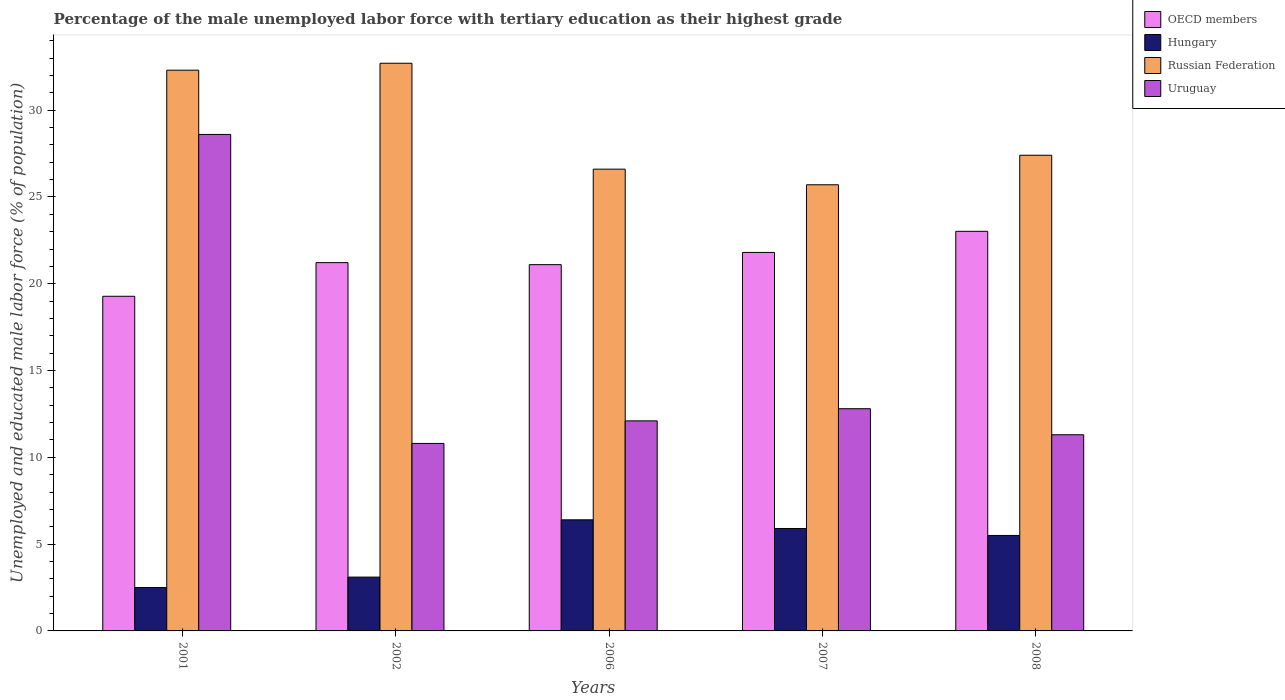How many different coloured bars are there?
Offer a very short reply. 4. How many groups of bars are there?
Your answer should be very brief. 5. Are the number of bars on each tick of the X-axis equal?
Provide a short and direct response. Yes. What is the label of the 3rd group of bars from the left?
Keep it short and to the point. 2006. What is the percentage of the unemployed male labor force with tertiary education in Russian Federation in 2006?
Offer a very short reply. 26.6. Across all years, what is the maximum percentage of the unemployed male labor force with tertiary education in OECD members?
Your answer should be very brief. 23.02. Across all years, what is the minimum percentage of the unemployed male labor force with tertiary education in Russian Federation?
Your response must be concise. 25.7. In which year was the percentage of the unemployed male labor force with tertiary education in Hungary minimum?
Provide a succinct answer. 2001. What is the total percentage of the unemployed male labor force with tertiary education in Hungary in the graph?
Make the answer very short. 23.4. What is the difference between the percentage of the unemployed male labor force with tertiary education in Hungary in 2002 and that in 2008?
Provide a short and direct response. -2.4. What is the difference between the percentage of the unemployed male labor force with tertiary education in Russian Federation in 2008 and the percentage of the unemployed male labor force with tertiary education in Uruguay in 2001?
Keep it short and to the point. -1.2. What is the average percentage of the unemployed male labor force with tertiary education in OECD members per year?
Offer a very short reply. 21.28. In the year 2001, what is the difference between the percentage of the unemployed male labor force with tertiary education in Uruguay and percentage of the unemployed male labor force with tertiary education in Hungary?
Offer a very short reply. 26.1. In how many years, is the percentage of the unemployed male labor force with tertiary education in Hungary greater than 2 %?
Provide a succinct answer. 5. What is the ratio of the percentage of the unemployed male labor force with tertiary education in Hungary in 2001 to that in 2006?
Offer a terse response. 0.39. Is the percentage of the unemployed male labor force with tertiary education in OECD members in 2002 less than that in 2008?
Your answer should be compact. Yes. What is the difference between the highest and the second highest percentage of the unemployed male labor force with tertiary education in Russian Federation?
Your response must be concise. 0.4. What is the difference between the highest and the lowest percentage of the unemployed male labor force with tertiary education in OECD members?
Keep it short and to the point. 3.74. What does the 4th bar from the left in 2008 represents?
Ensure brevity in your answer.  Uruguay. What does the 3rd bar from the right in 2006 represents?
Make the answer very short. Hungary. Is it the case that in every year, the sum of the percentage of the unemployed male labor force with tertiary education in Uruguay and percentage of the unemployed male labor force with tertiary education in Hungary is greater than the percentage of the unemployed male labor force with tertiary education in Russian Federation?
Provide a short and direct response. No. What is the difference between two consecutive major ticks on the Y-axis?
Provide a succinct answer. 5. Are the values on the major ticks of Y-axis written in scientific E-notation?
Provide a succinct answer. No. Does the graph contain any zero values?
Keep it short and to the point. No. Does the graph contain grids?
Your answer should be very brief. No. How many legend labels are there?
Provide a succinct answer. 4. How are the legend labels stacked?
Keep it short and to the point. Vertical. What is the title of the graph?
Give a very brief answer. Percentage of the male unemployed labor force with tertiary education as their highest grade. What is the label or title of the Y-axis?
Make the answer very short. Unemployed and educated male labor force (% of population). What is the Unemployed and educated male labor force (% of population) in OECD members in 2001?
Your answer should be very brief. 19.28. What is the Unemployed and educated male labor force (% of population) in Russian Federation in 2001?
Offer a terse response. 32.3. What is the Unemployed and educated male labor force (% of population) of Uruguay in 2001?
Provide a succinct answer. 28.6. What is the Unemployed and educated male labor force (% of population) in OECD members in 2002?
Your response must be concise. 21.21. What is the Unemployed and educated male labor force (% of population) in Hungary in 2002?
Make the answer very short. 3.1. What is the Unemployed and educated male labor force (% of population) in Russian Federation in 2002?
Ensure brevity in your answer.  32.7. What is the Unemployed and educated male labor force (% of population) of Uruguay in 2002?
Your answer should be very brief. 10.8. What is the Unemployed and educated male labor force (% of population) in OECD members in 2006?
Your response must be concise. 21.1. What is the Unemployed and educated male labor force (% of population) of Hungary in 2006?
Provide a short and direct response. 6.4. What is the Unemployed and educated male labor force (% of population) in Russian Federation in 2006?
Offer a terse response. 26.6. What is the Unemployed and educated male labor force (% of population) of Uruguay in 2006?
Make the answer very short. 12.1. What is the Unemployed and educated male labor force (% of population) of OECD members in 2007?
Provide a short and direct response. 21.8. What is the Unemployed and educated male labor force (% of population) in Hungary in 2007?
Provide a short and direct response. 5.9. What is the Unemployed and educated male labor force (% of population) in Russian Federation in 2007?
Give a very brief answer. 25.7. What is the Unemployed and educated male labor force (% of population) in Uruguay in 2007?
Provide a succinct answer. 12.8. What is the Unemployed and educated male labor force (% of population) in OECD members in 2008?
Offer a terse response. 23.02. What is the Unemployed and educated male labor force (% of population) of Russian Federation in 2008?
Keep it short and to the point. 27.4. What is the Unemployed and educated male labor force (% of population) in Uruguay in 2008?
Make the answer very short. 11.3. Across all years, what is the maximum Unemployed and educated male labor force (% of population) of OECD members?
Make the answer very short. 23.02. Across all years, what is the maximum Unemployed and educated male labor force (% of population) of Hungary?
Keep it short and to the point. 6.4. Across all years, what is the maximum Unemployed and educated male labor force (% of population) in Russian Federation?
Your answer should be very brief. 32.7. Across all years, what is the maximum Unemployed and educated male labor force (% of population) in Uruguay?
Your answer should be compact. 28.6. Across all years, what is the minimum Unemployed and educated male labor force (% of population) in OECD members?
Provide a short and direct response. 19.28. Across all years, what is the minimum Unemployed and educated male labor force (% of population) of Russian Federation?
Offer a terse response. 25.7. Across all years, what is the minimum Unemployed and educated male labor force (% of population) in Uruguay?
Provide a succinct answer. 10.8. What is the total Unemployed and educated male labor force (% of population) in OECD members in the graph?
Provide a succinct answer. 106.41. What is the total Unemployed and educated male labor force (% of population) in Hungary in the graph?
Ensure brevity in your answer.  23.4. What is the total Unemployed and educated male labor force (% of population) in Russian Federation in the graph?
Make the answer very short. 144.7. What is the total Unemployed and educated male labor force (% of population) in Uruguay in the graph?
Offer a terse response. 75.6. What is the difference between the Unemployed and educated male labor force (% of population) in OECD members in 2001 and that in 2002?
Ensure brevity in your answer.  -1.94. What is the difference between the Unemployed and educated male labor force (% of population) of Russian Federation in 2001 and that in 2002?
Ensure brevity in your answer.  -0.4. What is the difference between the Unemployed and educated male labor force (% of population) in OECD members in 2001 and that in 2006?
Your answer should be very brief. -1.82. What is the difference between the Unemployed and educated male labor force (% of population) in Hungary in 2001 and that in 2006?
Provide a short and direct response. -3.9. What is the difference between the Unemployed and educated male labor force (% of population) in Russian Federation in 2001 and that in 2006?
Your response must be concise. 5.7. What is the difference between the Unemployed and educated male labor force (% of population) of OECD members in 2001 and that in 2007?
Ensure brevity in your answer.  -2.53. What is the difference between the Unemployed and educated male labor force (% of population) of Hungary in 2001 and that in 2007?
Your answer should be very brief. -3.4. What is the difference between the Unemployed and educated male labor force (% of population) of OECD members in 2001 and that in 2008?
Provide a short and direct response. -3.74. What is the difference between the Unemployed and educated male labor force (% of population) of Hungary in 2001 and that in 2008?
Your answer should be very brief. -3. What is the difference between the Unemployed and educated male labor force (% of population) of Russian Federation in 2001 and that in 2008?
Provide a succinct answer. 4.9. What is the difference between the Unemployed and educated male labor force (% of population) in Uruguay in 2001 and that in 2008?
Provide a short and direct response. 17.3. What is the difference between the Unemployed and educated male labor force (% of population) of OECD members in 2002 and that in 2006?
Offer a terse response. 0.12. What is the difference between the Unemployed and educated male labor force (% of population) in OECD members in 2002 and that in 2007?
Ensure brevity in your answer.  -0.59. What is the difference between the Unemployed and educated male labor force (% of population) of Hungary in 2002 and that in 2007?
Ensure brevity in your answer.  -2.8. What is the difference between the Unemployed and educated male labor force (% of population) of Russian Federation in 2002 and that in 2007?
Give a very brief answer. 7. What is the difference between the Unemployed and educated male labor force (% of population) of Uruguay in 2002 and that in 2007?
Keep it short and to the point. -2. What is the difference between the Unemployed and educated male labor force (% of population) in OECD members in 2002 and that in 2008?
Provide a short and direct response. -1.8. What is the difference between the Unemployed and educated male labor force (% of population) of Russian Federation in 2002 and that in 2008?
Keep it short and to the point. 5.3. What is the difference between the Unemployed and educated male labor force (% of population) of Uruguay in 2002 and that in 2008?
Your answer should be very brief. -0.5. What is the difference between the Unemployed and educated male labor force (% of population) in OECD members in 2006 and that in 2007?
Ensure brevity in your answer.  -0.7. What is the difference between the Unemployed and educated male labor force (% of population) of Russian Federation in 2006 and that in 2007?
Make the answer very short. 0.9. What is the difference between the Unemployed and educated male labor force (% of population) of OECD members in 2006 and that in 2008?
Make the answer very short. -1.92. What is the difference between the Unemployed and educated male labor force (% of population) of Hungary in 2006 and that in 2008?
Your answer should be very brief. 0.9. What is the difference between the Unemployed and educated male labor force (% of population) of OECD members in 2007 and that in 2008?
Your response must be concise. -1.22. What is the difference between the Unemployed and educated male labor force (% of population) in Hungary in 2007 and that in 2008?
Provide a succinct answer. 0.4. What is the difference between the Unemployed and educated male labor force (% of population) in Russian Federation in 2007 and that in 2008?
Keep it short and to the point. -1.7. What is the difference between the Unemployed and educated male labor force (% of population) of OECD members in 2001 and the Unemployed and educated male labor force (% of population) of Hungary in 2002?
Offer a terse response. 16.18. What is the difference between the Unemployed and educated male labor force (% of population) of OECD members in 2001 and the Unemployed and educated male labor force (% of population) of Russian Federation in 2002?
Your response must be concise. -13.42. What is the difference between the Unemployed and educated male labor force (% of population) of OECD members in 2001 and the Unemployed and educated male labor force (% of population) of Uruguay in 2002?
Give a very brief answer. 8.48. What is the difference between the Unemployed and educated male labor force (% of population) in Hungary in 2001 and the Unemployed and educated male labor force (% of population) in Russian Federation in 2002?
Ensure brevity in your answer.  -30.2. What is the difference between the Unemployed and educated male labor force (% of population) of OECD members in 2001 and the Unemployed and educated male labor force (% of population) of Hungary in 2006?
Keep it short and to the point. 12.88. What is the difference between the Unemployed and educated male labor force (% of population) in OECD members in 2001 and the Unemployed and educated male labor force (% of population) in Russian Federation in 2006?
Make the answer very short. -7.32. What is the difference between the Unemployed and educated male labor force (% of population) of OECD members in 2001 and the Unemployed and educated male labor force (% of population) of Uruguay in 2006?
Give a very brief answer. 7.18. What is the difference between the Unemployed and educated male labor force (% of population) of Hungary in 2001 and the Unemployed and educated male labor force (% of population) of Russian Federation in 2006?
Your response must be concise. -24.1. What is the difference between the Unemployed and educated male labor force (% of population) of Russian Federation in 2001 and the Unemployed and educated male labor force (% of population) of Uruguay in 2006?
Provide a succinct answer. 20.2. What is the difference between the Unemployed and educated male labor force (% of population) in OECD members in 2001 and the Unemployed and educated male labor force (% of population) in Hungary in 2007?
Keep it short and to the point. 13.38. What is the difference between the Unemployed and educated male labor force (% of population) in OECD members in 2001 and the Unemployed and educated male labor force (% of population) in Russian Federation in 2007?
Offer a terse response. -6.42. What is the difference between the Unemployed and educated male labor force (% of population) of OECD members in 2001 and the Unemployed and educated male labor force (% of population) of Uruguay in 2007?
Offer a very short reply. 6.48. What is the difference between the Unemployed and educated male labor force (% of population) of Hungary in 2001 and the Unemployed and educated male labor force (% of population) of Russian Federation in 2007?
Your response must be concise. -23.2. What is the difference between the Unemployed and educated male labor force (% of population) in Hungary in 2001 and the Unemployed and educated male labor force (% of population) in Uruguay in 2007?
Your response must be concise. -10.3. What is the difference between the Unemployed and educated male labor force (% of population) in Russian Federation in 2001 and the Unemployed and educated male labor force (% of population) in Uruguay in 2007?
Your answer should be very brief. 19.5. What is the difference between the Unemployed and educated male labor force (% of population) in OECD members in 2001 and the Unemployed and educated male labor force (% of population) in Hungary in 2008?
Offer a terse response. 13.78. What is the difference between the Unemployed and educated male labor force (% of population) of OECD members in 2001 and the Unemployed and educated male labor force (% of population) of Russian Federation in 2008?
Provide a succinct answer. -8.12. What is the difference between the Unemployed and educated male labor force (% of population) of OECD members in 2001 and the Unemployed and educated male labor force (% of population) of Uruguay in 2008?
Offer a very short reply. 7.98. What is the difference between the Unemployed and educated male labor force (% of population) of Hungary in 2001 and the Unemployed and educated male labor force (% of population) of Russian Federation in 2008?
Provide a short and direct response. -24.9. What is the difference between the Unemployed and educated male labor force (% of population) in Hungary in 2001 and the Unemployed and educated male labor force (% of population) in Uruguay in 2008?
Offer a terse response. -8.8. What is the difference between the Unemployed and educated male labor force (% of population) of OECD members in 2002 and the Unemployed and educated male labor force (% of population) of Hungary in 2006?
Offer a very short reply. 14.81. What is the difference between the Unemployed and educated male labor force (% of population) of OECD members in 2002 and the Unemployed and educated male labor force (% of population) of Russian Federation in 2006?
Your answer should be compact. -5.39. What is the difference between the Unemployed and educated male labor force (% of population) in OECD members in 2002 and the Unemployed and educated male labor force (% of population) in Uruguay in 2006?
Offer a very short reply. 9.11. What is the difference between the Unemployed and educated male labor force (% of population) in Hungary in 2002 and the Unemployed and educated male labor force (% of population) in Russian Federation in 2006?
Keep it short and to the point. -23.5. What is the difference between the Unemployed and educated male labor force (% of population) in Russian Federation in 2002 and the Unemployed and educated male labor force (% of population) in Uruguay in 2006?
Your response must be concise. 20.6. What is the difference between the Unemployed and educated male labor force (% of population) of OECD members in 2002 and the Unemployed and educated male labor force (% of population) of Hungary in 2007?
Your answer should be very brief. 15.31. What is the difference between the Unemployed and educated male labor force (% of population) in OECD members in 2002 and the Unemployed and educated male labor force (% of population) in Russian Federation in 2007?
Provide a succinct answer. -4.49. What is the difference between the Unemployed and educated male labor force (% of population) of OECD members in 2002 and the Unemployed and educated male labor force (% of population) of Uruguay in 2007?
Offer a very short reply. 8.41. What is the difference between the Unemployed and educated male labor force (% of population) of Hungary in 2002 and the Unemployed and educated male labor force (% of population) of Russian Federation in 2007?
Keep it short and to the point. -22.6. What is the difference between the Unemployed and educated male labor force (% of population) of Hungary in 2002 and the Unemployed and educated male labor force (% of population) of Uruguay in 2007?
Provide a short and direct response. -9.7. What is the difference between the Unemployed and educated male labor force (% of population) of OECD members in 2002 and the Unemployed and educated male labor force (% of population) of Hungary in 2008?
Your response must be concise. 15.71. What is the difference between the Unemployed and educated male labor force (% of population) of OECD members in 2002 and the Unemployed and educated male labor force (% of population) of Russian Federation in 2008?
Offer a terse response. -6.19. What is the difference between the Unemployed and educated male labor force (% of population) in OECD members in 2002 and the Unemployed and educated male labor force (% of population) in Uruguay in 2008?
Your response must be concise. 9.91. What is the difference between the Unemployed and educated male labor force (% of population) in Hungary in 2002 and the Unemployed and educated male labor force (% of population) in Russian Federation in 2008?
Provide a short and direct response. -24.3. What is the difference between the Unemployed and educated male labor force (% of population) of Hungary in 2002 and the Unemployed and educated male labor force (% of population) of Uruguay in 2008?
Your answer should be very brief. -8.2. What is the difference between the Unemployed and educated male labor force (% of population) of Russian Federation in 2002 and the Unemployed and educated male labor force (% of population) of Uruguay in 2008?
Make the answer very short. 21.4. What is the difference between the Unemployed and educated male labor force (% of population) in OECD members in 2006 and the Unemployed and educated male labor force (% of population) in Hungary in 2007?
Provide a short and direct response. 15.2. What is the difference between the Unemployed and educated male labor force (% of population) in OECD members in 2006 and the Unemployed and educated male labor force (% of population) in Russian Federation in 2007?
Provide a short and direct response. -4.6. What is the difference between the Unemployed and educated male labor force (% of population) of OECD members in 2006 and the Unemployed and educated male labor force (% of population) of Uruguay in 2007?
Provide a short and direct response. 8.3. What is the difference between the Unemployed and educated male labor force (% of population) in Hungary in 2006 and the Unemployed and educated male labor force (% of population) in Russian Federation in 2007?
Your response must be concise. -19.3. What is the difference between the Unemployed and educated male labor force (% of population) of Russian Federation in 2006 and the Unemployed and educated male labor force (% of population) of Uruguay in 2007?
Offer a terse response. 13.8. What is the difference between the Unemployed and educated male labor force (% of population) in OECD members in 2006 and the Unemployed and educated male labor force (% of population) in Hungary in 2008?
Your answer should be very brief. 15.6. What is the difference between the Unemployed and educated male labor force (% of population) of OECD members in 2006 and the Unemployed and educated male labor force (% of population) of Russian Federation in 2008?
Make the answer very short. -6.3. What is the difference between the Unemployed and educated male labor force (% of population) of OECD members in 2006 and the Unemployed and educated male labor force (% of population) of Uruguay in 2008?
Provide a succinct answer. 9.8. What is the difference between the Unemployed and educated male labor force (% of population) of Russian Federation in 2006 and the Unemployed and educated male labor force (% of population) of Uruguay in 2008?
Give a very brief answer. 15.3. What is the difference between the Unemployed and educated male labor force (% of population) of OECD members in 2007 and the Unemployed and educated male labor force (% of population) of Hungary in 2008?
Make the answer very short. 16.3. What is the difference between the Unemployed and educated male labor force (% of population) in OECD members in 2007 and the Unemployed and educated male labor force (% of population) in Russian Federation in 2008?
Keep it short and to the point. -5.6. What is the difference between the Unemployed and educated male labor force (% of population) of OECD members in 2007 and the Unemployed and educated male labor force (% of population) of Uruguay in 2008?
Ensure brevity in your answer.  10.5. What is the difference between the Unemployed and educated male labor force (% of population) of Hungary in 2007 and the Unemployed and educated male labor force (% of population) of Russian Federation in 2008?
Offer a terse response. -21.5. What is the difference between the Unemployed and educated male labor force (% of population) in Hungary in 2007 and the Unemployed and educated male labor force (% of population) in Uruguay in 2008?
Make the answer very short. -5.4. What is the average Unemployed and educated male labor force (% of population) of OECD members per year?
Ensure brevity in your answer.  21.28. What is the average Unemployed and educated male labor force (% of population) of Hungary per year?
Provide a short and direct response. 4.68. What is the average Unemployed and educated male labor force (% of population) in Russian Federation per year?
Offer a very short reply. 28.94. What is the average Unemployed and educated male labor force (% of population) in Uruguay per year?
Provide a succinct answer. 15.12. In the year 2001, what is the difference between the Unemployed and educated male labor force (% of population) of OECD members and Unemployed and educated male labor force (% of population) of Hungary?
Make the answer very short. 16.78. In the year 2001, what is the difference between the Unemployed and educated male labor force (% of population) in OECD members and Unemployed and educated male labor force (% of population) in Russian Federation?
Offer a very short reply. -13.02. In the year 2001, what is the difference between the Unemployed and educated male labor force (% of population) of OECD members and Unemployed and educated male labor force (% of population) of Uruguay?
Your answer should be very brief. -9.32. In the year 2001, what is the difference between the Unemployed and educated male labor force (% of population) of Hungary and Unemployed and educated male labor force (% of population) of Russian Federation?
Your answer should be very brief. -29.8. In the year 2001, what is the difference between the Unemployed and educated male labor force (% of population) in Hungary and Unemployed and educated male labor force (% of population) in Uruguay?
Make the answer very short. -26.1. In the year 2001, what is the difference between the Unemployed and educated male labor force (% of population) in Russian Federation and Unemployed and educated male labor force (% of population) in Uruguay?
Your response must be concise. 3.7. In the year 2002, what is the difference between the Unemployed and educated male labor force (% of population) in OECD members and Unemployed and educated male labor force (% of population) in Hungary?
Give a very brief answer. 18.11. In the year 2002, what is the difference between the Unemployed and educated male labor force (% of population) in OECD members and Unemployed and educated male labor force (% of population) in Russian Federation?
Your answer should be compact. -11.49. In the year 2002, what is the difference between the Unemployed and educated male labor force (% of population) in OECD members and Unemployed and educated male labor force (% of population) in Uruguay?
Your response must be concise. 10.41. In the year 2002, what is the difference between the Unemployed and educated male labor force (% of population) of Hungary and Unemployed and educated male labor force (% of population) of Russian Federation?
Keep it short and to the point. -29.6. In the year 2002, what is the difference between the Unemployed and educated male labor force (% of population) of Hungary and Unemployed and educated male labor force (% of population) of Uruguay?
Keep it short and to the point. -7.7. In the year 2002, what is the difference between the Unemployed and educated male labor force (% of population) of Russian Federation and Unemployed and educated male labor force (% of population) of Uruguay?
Ensure brevity in your answer.  21.9. In the year 2006, what is the difference between the Unemployed and educated male labor force (% of population) in OECD members and Unemployed and educated male labor force (% of population) in Hungary?
Keep it short and to the point. 14.7. In the year 2006, what is the difference between the Unemployed and educated male labor force (% of population) of OECD members and Unemployed and educated male labor force (% of population) of Russian Federation?
Keep it short and to the point. -5.5. In the year 2006, what is the difference between the Unemployed and educated male labor force (% of population) in OECD members and Unemployed and educated male labor force (% of population) in Uruguay?
Keep it short and to the point. 9. In the year 2006, what is the difference between the Unemployed and educated male labor force (% of population) of Hungary and Unemployed and educated male labor force (% of population) of Russian Federation?
Your answer should be compact. -20.2. In the year 2006, what is the difference between the Unemployed and educated male labor force (% of population) of Hungary and Unemployed and educated male labor force (% of population) of Uruguay?
Make the answer very short. -5.7. In the year 2006, what is the difference between the Unemployed and educated male labor force (% of population) of Russian Federation and Unemployed and educated male labor force (% of population) of Uruguay?
Provide a short and direct response. 14.5. In the year 2007, what is the difference between the Unemployed and educated male labor force (% of population) of OECD members and Unemployed and educated male labor force (% of population) of Hungary?
Offer a terse response. 15.9. In the year 2007, what is the difference between the Unemployed and educated male labor force (% of population) in OECD members and Unemployed and educated male labor force (% of population) in Russian Federation?
Make the answer very short. -3.9. In the year 2007, what is the difference between the Unemployed and educated male labor force (% of population) of OECD members and Unemployed and educated male labor force (% of population) of Uruguay?
Offer a very short reply. 9. In the year 2007, what is the difference between the Unemployed and educated male labor force (% of population) of Hungary and Unemployed and educated male labor force (% of population) of Russian Federation?
Offer a very short reply. -19.8. In the year 2008, what is the difference between the Unemployed and educated male labor force (% of population) in OECD members and Unemployed and educated male labor force (% of population) in Hungary?
Your answer should be very brief. 17.52. In the year 2008, what is the difference between the Unemployed and educated male labor force (% of population) of OECD members and Unemployed and educated male labor force (% of population) of Russian Federation?
Offer a terse response. -4.38. In the year 2008, what is the difference between the Unemployed and educated male labor force (% of population) in OECD members and Unemployed and educated male labor force (% of population) in Uruguay?
Your response must be concise. 11.72. In the year 2008, what is the difference between the Unemployed and educated male labor force (% of population) in Hungary and Unemployed and educated male labor force (% of population) in Russian Federation?
Keep it short and to the point. -21.9. In the year 2008, what is the difference between the Unemployed and educated male labor force (% of population) in Hungary and Unemployed and educated male labor force (% of population) in Uruguay?
Your answer should be very brief. -5.8. In the year 2008, what is the difference between the Unemployed and educated male labor force (% of population) of Russian Federation and Unemployed and educated male labor force (% of population) of Uruguay?
Provide a short and direct response. 16.1. What is the ratio of the Unemployed and educated male labor force (% of population) of OECD members in 2001 to that in 2002?
Provide a succinct answer. 0.91. What is the ratio of the Unemployed and educated male labor force (% of population) of Hungary in 2001 to that in 2002?
Ensure brevity in your answer.  0.81. What is the ratio of the Unemployed and educated male labor force (% of population) of Russian Federation in 2001 to that in 2002?
Your response must be concise. 0.99. What is the ratio of the Unemployed and educated male labor force (% of population) in Uruguay in 2001 to that in 2002?
Make the answer very short. 2.65. What is the ratio of the Unemployed and educated male labor force (% of population) of OECD members in 2001 to that in 2006?
Your response must be concise. 0.91. What is the ratio of the Unemployed and educated male labor force (% of population) in Hungary in 2001 to that in 2006?
Provide a short and direct response. 0.39. What is the ratio of the Unemployed and educated male labor force (% of population) in Russian Federation in 2001 to that in 2006?
Offer a very short reply. 1.21. What is the ratio of the Unemployed and educated male labor force (% of population) of Uruguay in 2001 to that in 2006?
Your answer should be very brief. 2.36. What is the ratio of the Unemployed and educated male labor force (% of population) in OECD members in 2001 to that in 2007?
Offer a very short reply. 0.88. What is the ratio of the Unemployed and educated male labor force (% of population) of Hungary in 2001 to that in 2007?
Provide a short and direct response. 0.42. What is the ratio of the Unemployed and educated male labor force (% of population) in Russian Federation in 2001 to that in 2007?
Your answer should be compact. 1.26. What is the ratio of the Unemployed and educated male labor force (% of population) in Uruguay in 2001 to that in 2007?
Provide a short and direct response. 2.23. What is the ratio of the Unemployed and educated male labor force (% of population) in OECD members in 2001 to that in 2008?
Ensure brevity in your answer.  0.84. What is the ratio of the Unemployed and educated male labor force (% of population) of Hungary in 2001 to that in 2008?
Offer a terse response. 0.45. What is the ratio of the Unemployed and educated male labor force (% of population) of Russian Federation in 2001 to that in 2008?
Provide a short and direct response. 1.18. What is the ratio of the Unemployed and educated male labor force (% of population) of Uruguay in 2001 to that in 2008?
Ensure brevity in your answer.  2.53. What is the ratio of the Unemployed and educated male labor force (% of population) in OECD members in 2002 to that in 2006?
Keep it short and to the point. 1.01. What is the ratio of the Unemployed and educated male labor force (% of population) in Hungary in 2002 to that in 2006?
Provide a succinct answer. 0.48. What is the ratio of the Unemployed and educated male labor force (% of population) in Russian Federation in 2002 to that in 2006?
Give a very brief answer. 1.23. What is the ratio of the Unemployed and educated male labor force (% of population) of Uruguay in 2002 to that in 2006?
Your answer should be compact. 0.89. What is the ratio of the Unemployed and educated male labor force (% of population) of Hungary in 2002 to that in 2007?
Offer a terse response. 0.53. What is the ratio of the Unemployed and educated male labor force (% of population) in Russian Federation in 2002 to that in 2007?
Provide a short and direct response. 1.27. What is the ratio of the Unemployed and educated male labor force (% of population) in Uruguay in 2002 to that in 2007?
Offer a terse response. 0.84. What is the ratio of the Unemployed and educated male labor force (% of population) in OECD members in 2002 to that in 2008?
Your response must be concise. 0.92. What is the ratio of the Unemployed and educated male labor force (% of population) in Hungary in 2002 to that in 2008?
Offer a very short reply. 0.56. What is the ratio of the Unemployed and educated male labor force (% of population) of Russian Federation in 2002 to that in 2008?
Your answer should be very brief. 1.19. What is the ratio of the Unemployed and educated male labor force (% of population) of Uruguay in 2002 to that in 2008?
Provide a short and direct response. 0.96. What is the ratio of the Unemployed and educated male labor force (% of population) of Hungary in 2006 to that in 2007?
Give a very brief answer. 1.08. What is the ratio of the Unemployed and educated male labor force (% of population) of Russian Federation in 2006 to that in 2007?
Your response must be concise. 1.03. What is the ratio of the Unemployed and educated male labor force (% of population) of Uruguay in 2006 to that in 2007?
Offer a very short reply. 0.95. What is the ratio of the Unemployed and educated male labor force (% of population) of OECD members in 2006 to that in 2008?
Offer a very short reply. 0.92. What is the ratio of the Unemployed and educated male labor force (% of population) in Hungary in 2006 to that in 2008?
Provide a succinct answer. 1.16. What is the ratio of the Unemployed and educated male labor force (% of population) of Russian Federation in 2006 to that in 2008?
Make the answer very short. 0.97. What is the ratio of the Unemployed and educated male labor force (% of population) in Uruguay in 2006 to that in 2008?
Offer a very short reply. 1.07. What is the ratio of the Unemployed and educated male labor force (% of population) of OECD members in 2007 to that in 2008?
Offer a terse response. 0.95. What is the ratio of the Unemployed and educated male labor force (% of population) of Hungary in 2007 to that in 2008?
Make the answer very short. 1.07. What is the ratio of the Unemployed and educated male labor force (% of population) in Russian Federation in 2007 to that in 2008?
Your response must be concise. 0.94. What is the ratio of the Unemployed and educated male labor force (% of population) of Uruguay in 2007 to that in 2008?
Offer a very short reply. 1.13. What is the difference between the highest and the second highest Unemployed and educated male labor force (% of population) in OECD members?
Offer a terse response. 1.22. What is the difference between the highest and the second highest Unemployed and educated male labor force (% of population) in Uruguay?
Keep it short and to the point. 15.8. What is the difference between the highest and the lowest Unemployed and educated male labor force (% of population) of OECD members?
Your response must be concise. 3.74. What is the difference between the highest and the lowest Unemployed and educated male labor force (% of population) in Russian Federation?
Make the answer very short. 7. 